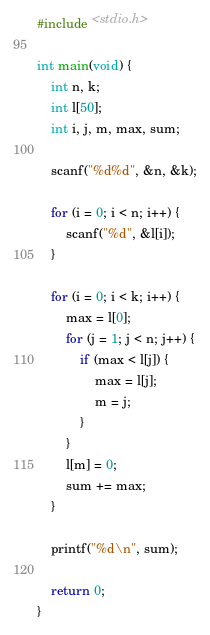<code> <loc_0><loc_0><loc_500><loc_500><_C_>#include <stdio.h>
      
int main(void) {
	int n, k;
	int l[50];
	int i, j, m, max, sum;

    scanf("%d%d", &n, &k);
    
    for (i = 0; i < n; i++) {
		scanf("%d", &l[i]);
	}
   
    for (i = 0; i < k; i++) {
    	max = l[0];
    	for (j = 1; j < n; j++) {
        	if (max < l[j]) {
            	max = l[j];
            	m = j;
        	}
    	}
    	l[m] = 0;
    	sum += max;
    }
    
    printf("%d\n", sum);
    
    return 0;
}</code> 